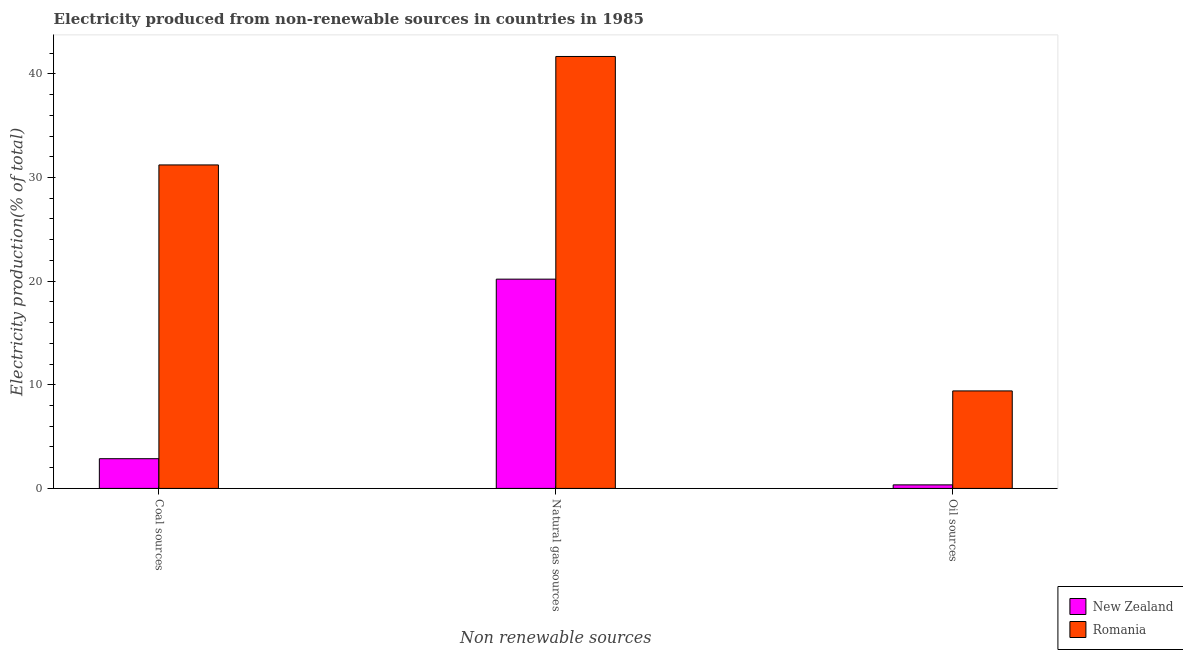How many different coloured bars are there?
Your answer should be compact. 2. How many groups of bars are there?
Make the answer very short. 3. Are the number of bars per tick equal to the number of legend labels?
Offer a very short reply. Yes. Are the number of bars on each tick of the X-axis equal?
Provide a succinct answer. Yes. How many bars are there on the 2nd tick from the left?
Ensure brevity in your answer.  2. How many bars are there on the 1st tick from the right?
Keep it short and to the point. 2. What is the label of the 3rd group of bars from the left?
Provide a succinct answer. Oil sources. What is the percentage of electricity produced by coal in New Zealand?
Your response must be concise. 2.87. Across all countries, what is the maximum percentage of electricity produced by natural gas?
Provide a succinct answer. 41.68. Across all countries, what is the minimum percentage of electricity produced by coal?
Give a very brief answer. 2.87. In which country was the percentage of electricity produced by oil sources maximum?
Keep it short and to the point. Romania. In which country was the percentage of electricity produced by natural gas minimum?
Your answer should be very brief. New Zealand. What is the total percentage of electricity produced by natural gas in the graph?
Provide a short and direct response. 61.87. What is the difference between the percentage of electricity produced by coal in New Zealand and that in Romania?
Offer a very short reply. -28.34. What is the difference between the percentage of electricity produced by natural gas in New Zealand and the percentage of electricity produced by oil sources in Romania?
Ensure brevity in your answer.  10.78. What is the average percentage of electricity produced by oil sources per country?
Give a very brief answer. 4.88. What is the difference between the percentage of electricity produced by coal and percentage of electricity produced by oil sources in Romania?
Your answer should be very brief. 21.8. What is the ratio of the percentage of electricity produced by coal in Romania to that in New Zealand?
Offer a very short reply. 10.88. Is the percentage of electricity produced by coal in New Zealand less than that in Romania?
Your answer should be compact. Yes. What is the difference between the highest and the second highest percentage of electricity produced by oil sources?
Your response must be concise. 9.07. What is the difference between the highest and the lowest percentage of electricity produced by coal?
Provide a succinct answer. 28.34. Is the sum of the percentage of electricity produced by natural gas in New Zealand and Romania greater than the maximum percentage of electricity produced by coal across all countries?
Your answer should be compact. Yes. What does the 1st bar from the left in Coal sources represents?
Your answer should be compact. New Zealand. What does the 2nd bar from the right in Oil sources represents?
Offer a very short reply. New Zealand. Are all the bars in the graph horizontal?
Your answer should be compact. No. How many countries are there in the graph?
Ensure brevity in your answer.  2. Are the values on the major ticks of Y-axis written in scientific E-notation?
Offer a terse response. No. Does the graph contain grids?
Keep it short and to the point. No. Where does the legend appear in the graph?
Give a very brief answer. Bottom right. How many legend labels are there?
Make the answer very short. 2. How are the legend labels stacked?
Give a very brief answer. Vertical. What is the title of the graph?
Ensure brevity in your answer.  Electricity produced from non-renewable sources in countries in 1985. What is the label or title of the X-axis?
Offer a terse response. Non renewable sources. What is the label or title of the Y-axis?
Offer a very short reply. Electricity production(% of total). What is the Electricity production(% of total) in New Zealand in Coal sources?
Ensure brevity in your answer.  2.87. What is the Electricity production(% of total) of Romania in Coal sources?
Offer a very short reply. 31.21. What is the Electricity production(% of total) in New Zealand in Natural gas sources?
Your answer should be compact. 20.19. What is the Electricity production(% of total) in Romania in Natural gas sources?
Offer a very short reply. 41.68. What is the Electricity production(% of total) of New Zealand in Oil sources?
Offer a very short reply. 0.34. What is the Electricity production(% of total) of Romania in Oil sources?
Ensure brevity in your answer.  9.41. Across all Non renewable sources, what is the maximum Electricity production(% of total) in New Zealand?
Offer a very short reply. 20.19. Across all Non renewable sources, what is the maximum Electricity production(% of total) in Romania?
Offer a very short reply. 41.68. Across all Non renewable sources, what is the minimum Electricity production(% of total) in New Zealand?
Provide a succinct answer. 0.34. Across all Non renewable sources, what is the minimum Electricity production(% of total) of Romania?
Offer a terse response. 9.41. What is the total Electricity production(% of total) in New Zealand in the graph?
Provide a short and direct response. 23.4. What is the total Electricity production(% of total) of Romania in the graph?
Offer a very short reply. 82.3. What is the difference between the Electricity production(% of total) in New Zealand in Coal sources and that in Natural gas sources?
Your answer should be compact. -17.32. What is the difference between the Electricity production(% of total) of Romania in Coal sources and that in Natural gas sources?
Give a very brief answer. -10.47. What is the difference between the Electricity production(% of total) of New Zealand in Coal sources and that in Oil sources?
Provide a succinct answer. 2.52. What is the difference between the Electricity production(% of total) of Romania in Coal sources and that in Oil sources?
Your response must be concise. 21.8. What is the difference between the Electricity production(% of total) in New Zealand in Natural gas sources and that in Oil sources?
Your response must be concise. 19.85. What is the difference between the Electricity production(% of total) of Romania in Natural gas sources and that in Oil sources?
Your answer should be compact. 32.27. What is the difference between the Electricity production(% of total) of New Zealand in Coal sources and the Electricity production(% of total) of Romania in Natural gas sources?
Give a very brief answer. -38.81. What is the difference between the Electricity production(% of total) in New Zealand in Coal sources and the Electricity production(% of total) in Romania in Oil sources?
Provide a succinct answer. -6.54. What is the difference between the Electricity production(% of total) of New Zealand in Natural gas sources and the Electricity production(% of total) of Romania in Oil sources?
Your answer should be compact. 10.78. What is the average Electricity production(% of total) of New Zealand per Non renewable sources?
Provide a succinct answer. 7.8. What is the average Electricity production(% of total) of Romania per Non renewable sources?
Give a very brief answer. 27.43. What is the difference between the Electricity production(% of total) in New Zealand and Electricity production(% of total) in Romania in Coal sources?
Your response must be concise. -28.34. What is the difference between the Electricity production(% of total) in New Zealand and Electricity production(% of total) in Romania in Natural gas sources?
Your answer should be compact. -21.49. What is the difference between the Electricity production(% of total) of New Zealand and Electricity production(% of total) of Romania in Oil sources?
Offer a terse response. -9.07. What is the ratio of the Electricity production(% of total) in New Zealand in Coal sources to that in Natural gas sources?
Your answer should be very brief. 0.14. What is the ratio of the Electricity production(% of total) in Romania in Coal sources to that in Natural gas sources?
Your response must be concise. 0.75. What is the ratio of the Electricity production(% of total) of New Zealand in Coal sources to that in Oil sources?
Provide a succinct answer. 8.37. What is the ratio of the Electricity production(% of total) in Romania in Coal sources to that in Oil sources?
Keep it short and to the point. 3.32. What is the ratio of the Electricity production(% of total) of New Zealand in Natural gas sources to that in Oil sources?
Your answer should be compact. 58.93. What is the ratio of the Electricity production(% of total) of Romania in Natural gas sources to that in Oil sources?
Offer a very short reply. 4.43. What is the difference between the highest and the second highest Electricity production(% of total) of New Zealand?
Your answer should be compact. 17.32. What is the difference between the highest and the second highest Electricity production(% of total) in Romania?
Give a very brief answer. 10.47. What is the difference between the highest and the lowest Electricity production(% of total) of New Zealand?
Keep it short and to the point. 19.85. What is the difference between the highest and the lowest Electricity production(% of total) in Romania?
Your answer should be compact. 32.27. 